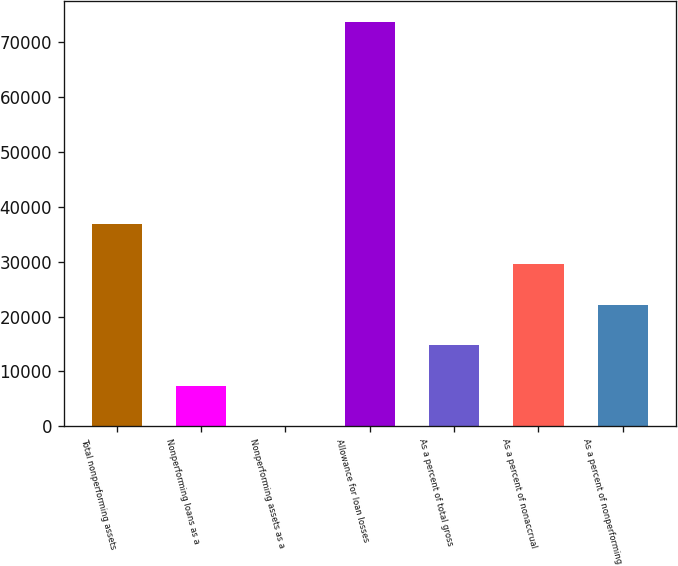Convert chart. <chart><loc_0><loc_0><loc_500><loc_500><bar_chart><fcel>Total nonperforming assets<fcel>Nonperforming loans as a<fcel>Nonperforming assets as a<fcel>Allowance for loan losses<fcel>As a percent of total gross<fcel>As a percent of nonaccrual<fcel>As a percent of nonperforming<nl><fcel>36900.2<fcel>7380.27<fcel>0.3<fcel>73800<fcel>14760.2<fcel>29520.2<fcel>22140.2<nl></chart> 